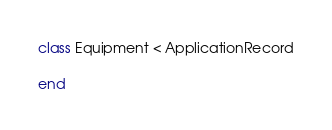<code> <loc_0><loc_0><loc_500><loc_500><_Ruby_>class Equipment < ApplicationRecord

end
</code> 